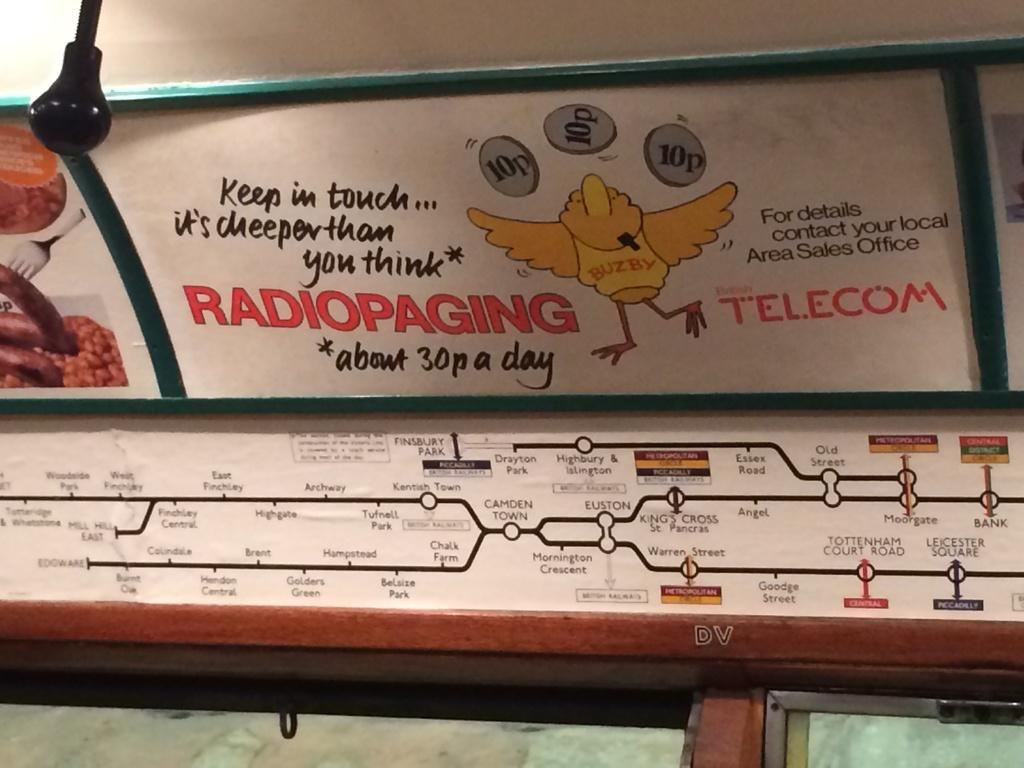Provide a one-sentence caption for the provided image. Ad on a train that has a chicken and is from Telecom. 